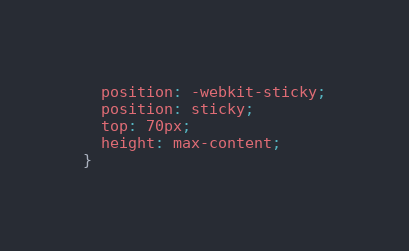<code> <loc_0><loc_0><loc_500><loc_500><_CSS_>  position: -webkit-sticky;
  position: sticky;
  top: 70px;
  height: max-content;
}
</code> 